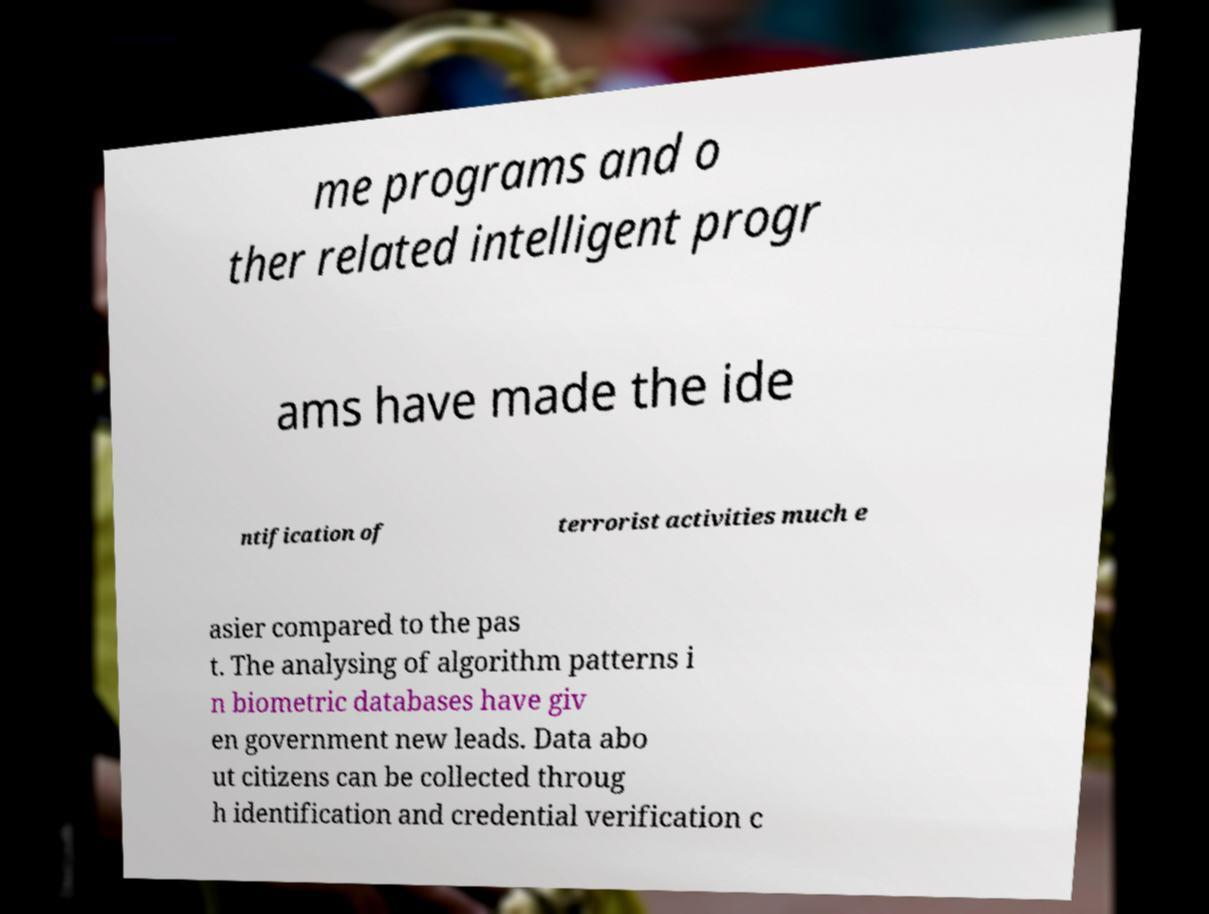Please identify and transcribe the text found in this image. me programs and o ther related intelligent progr ams have made the ide ntification of terrorist activities much e asier compared to the pas t. The analysing of algorithm patterns i n biometric databases have giv en government new leads. Data abo ut citizens can be collected throug h identification and credential verification c 